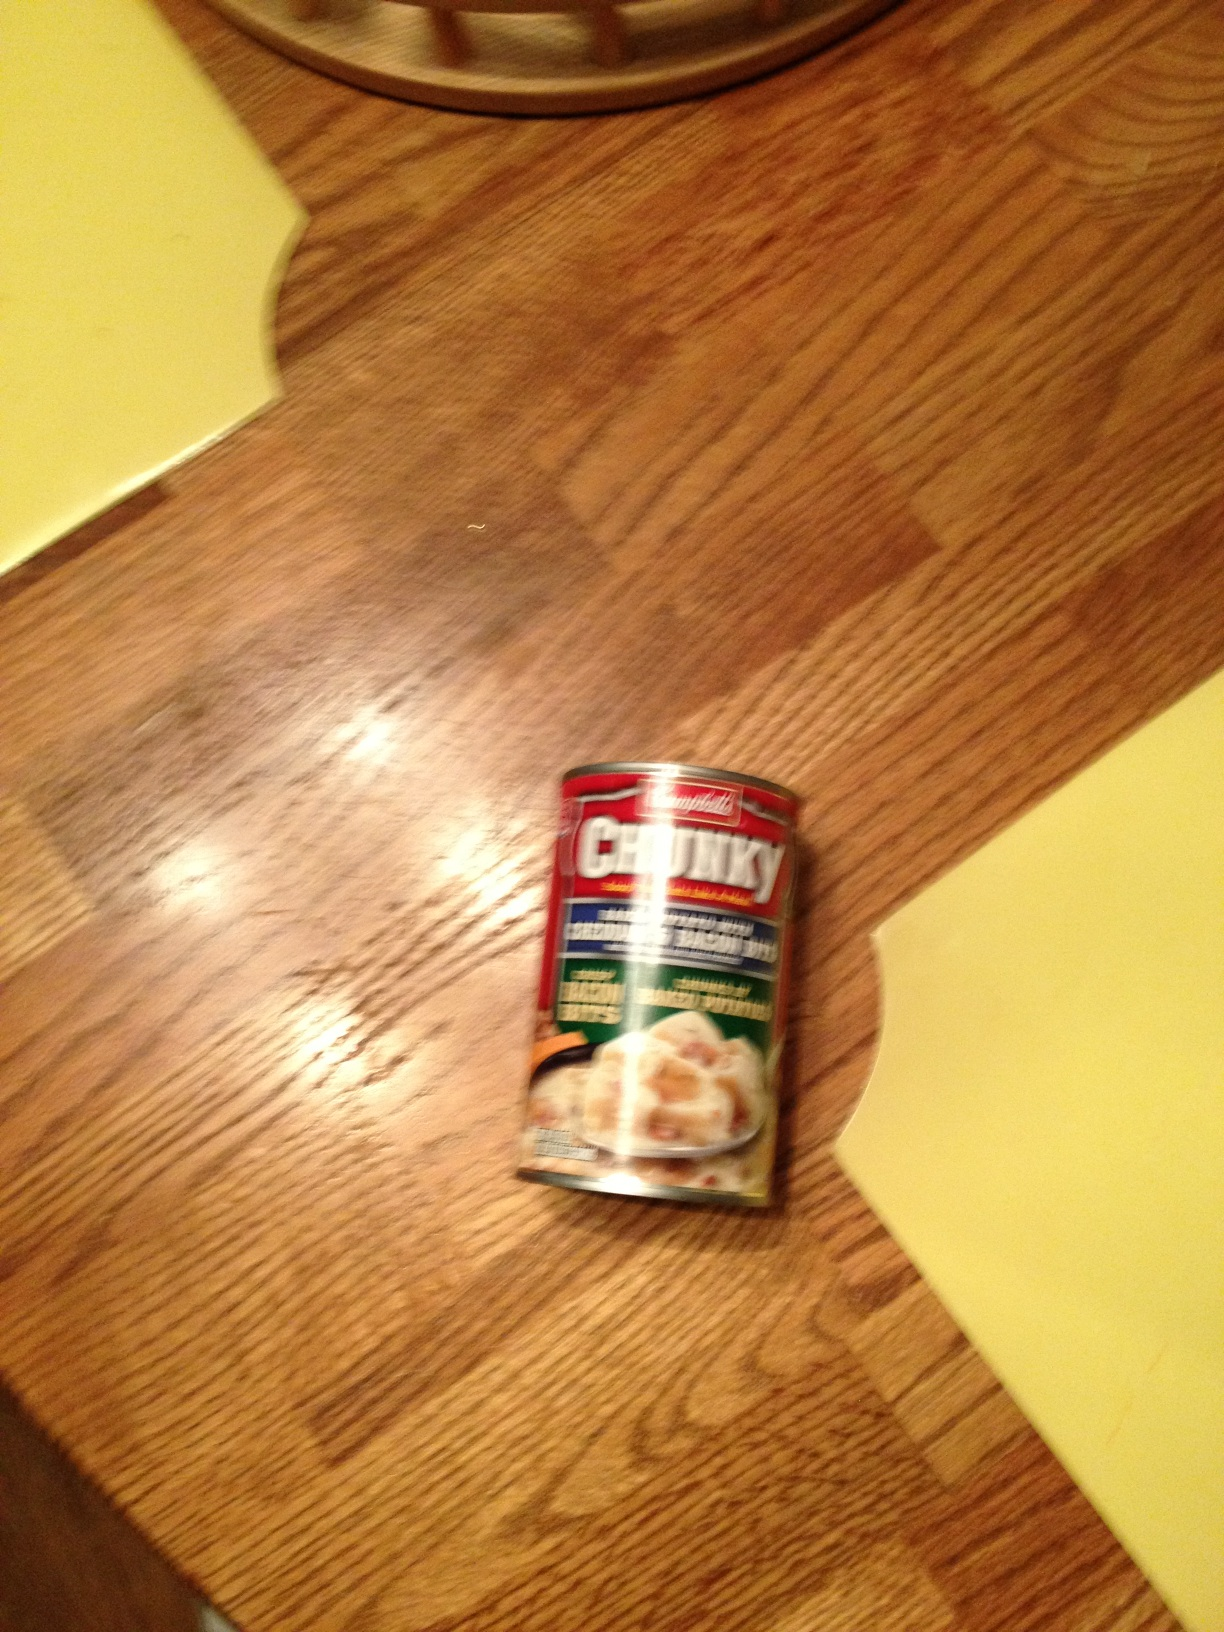What kind of soup is shown in the image? The image shows a can of Chunky soup, which appears to be a type of chicken soup, possibly with noodles or dumplings. 